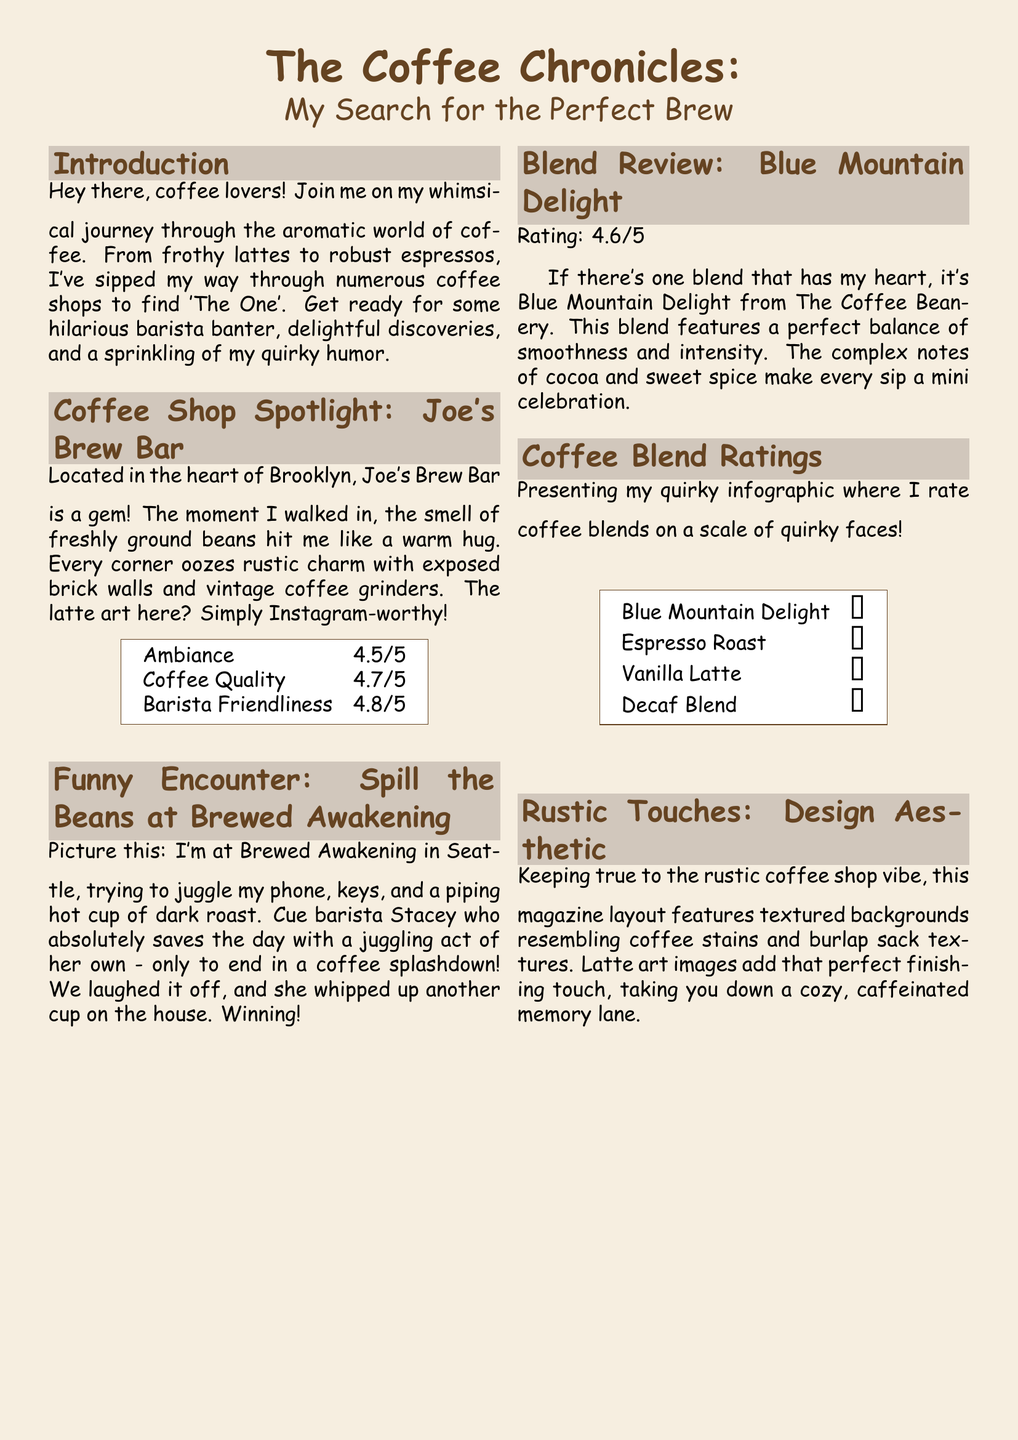What is the name of the first coffee shop featured? The document features Joe's Brew Bar as the first coffee shop spotlighted.
Answer: Joe's Brew Bar What is the rating for Barista Friendliness at Joe's Brew Bar? The document indicates the Barista Friendliness rating at Joe's Brew Bar is 4.8 out of 5.
Answer: 4.8/5 What funny incident occurred at Brewed Awakening? The funny incident involved a coffee splashdown during a juggling act by the barista.
Answer: Coffee splashdown What is the rating for the Blue Mountain Delight blend? The document provides a rating of 4.6 out of 5 for the Blue Mountain Delight blend.
Answer: 4.6/5 Which coffee blend received the 😍 rating? The Blue Mountain Delight blend is rated with a quirky face of 😍.
Answer: Blue Mountain Delight What style of font is used for the document's main text? The main text in the document is styled in Comic Sans MS font.
Answer: Comic Sans MS What design elements are used to achieve a rustic coffee shop vibe? The design uses textured backgrounds resembling coffee stains and burlap sack textures.
Answer: Textured backgrounds How is the quality of coffee rated at Joe's Brew Bar? The document states the Coffee Quality at Joe's Brew Bar is rated 4.7 out of 5.
Answer: 4.7/5 